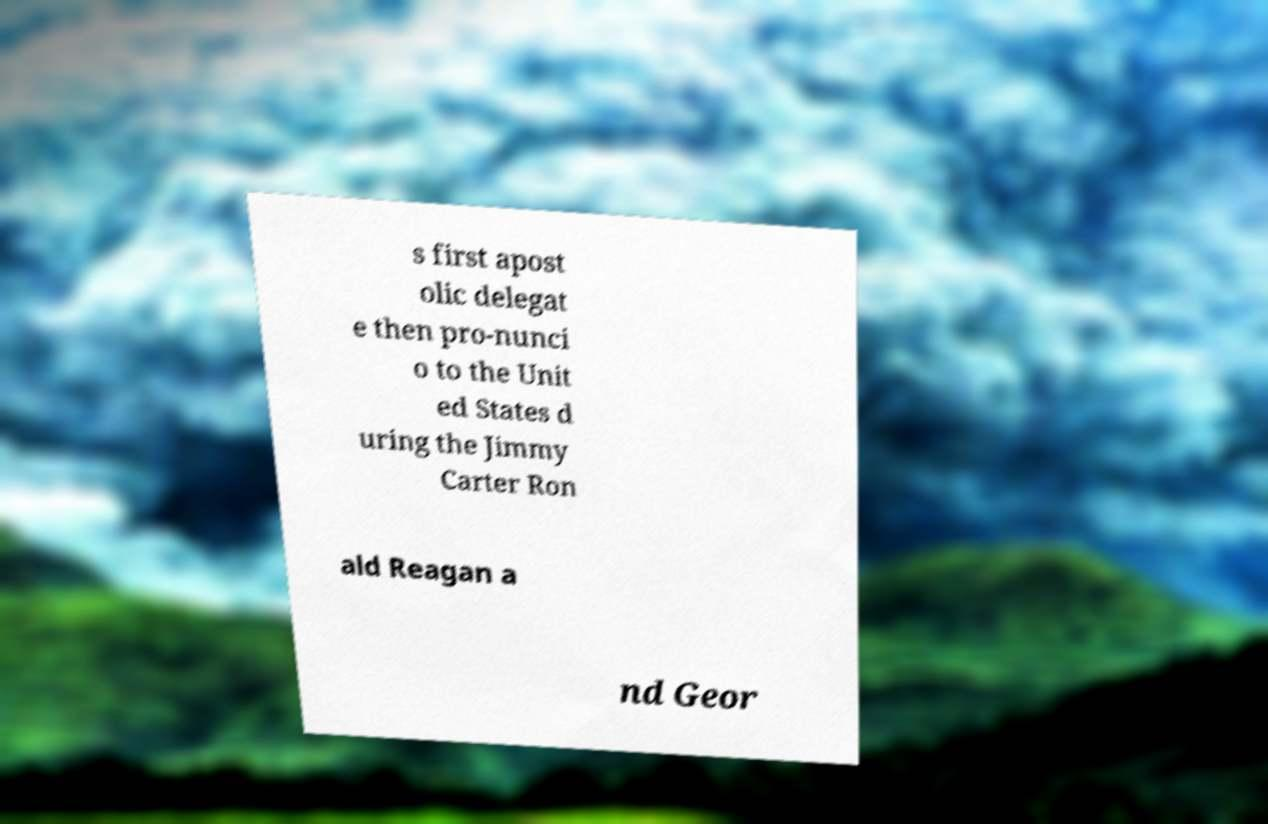Could you extract and type out the text from this image? s first apost olic delegat e then pro-nunci o to the Unit ed States d uring the Jimmy Carter Ron ald Reagan a nd Geor 